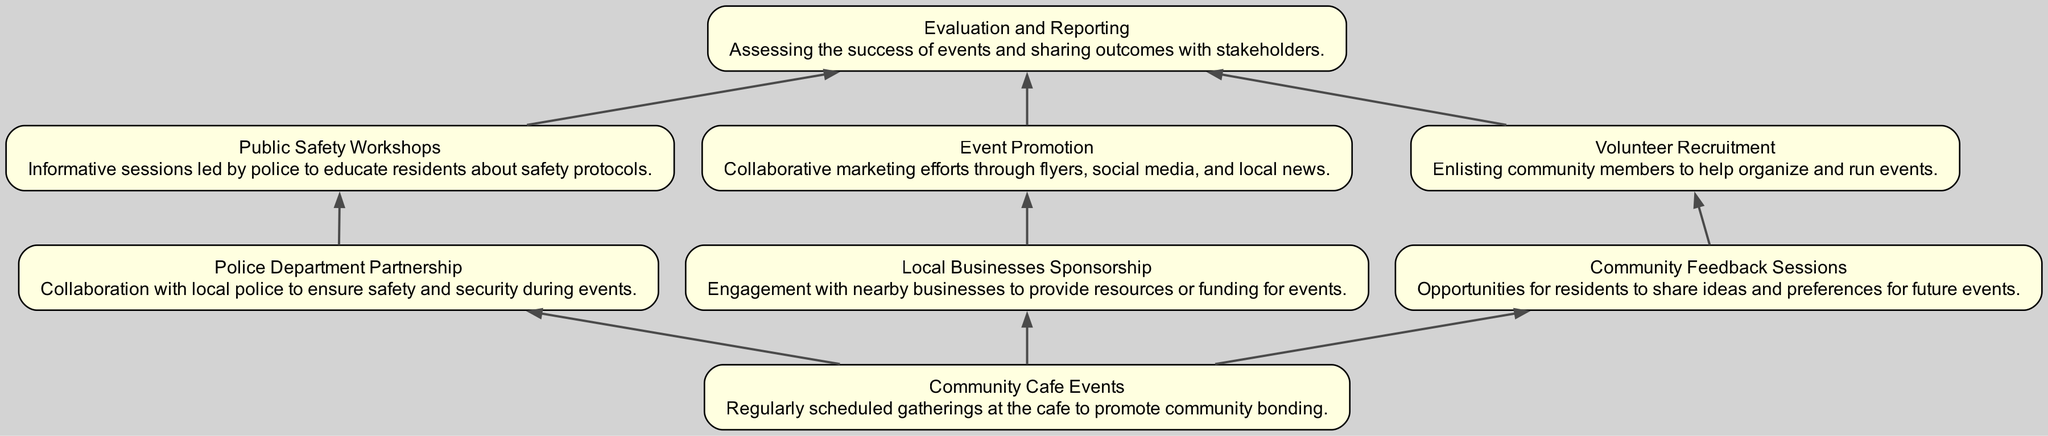What is the main purpose of Community Cafe Events? The main purpose of Community Cafe Events, as described in the diagram, is to promote community bonding through regularly scheduled gatherings.
Answer: Promote community bonding How many nodes are in the diagram? By counting each unique element listed in the diagram, we can see that there are a total of eight distinct nodes present.
Answer: Eight What connects Local Businesses Sponsorship to Evaluation and Reporting? The connection between Local Businesses Sponsorship and Evaluation and Reporting occurs through the Event Promotion, which is sponsored by local businesses.
Answer: Event Promotion Which node leads to Public Safety Workshops? The node that leads to Public Safety Workshops is the Police Department Partnership, indicating a direct connection in the flow of the diagram.
Answer: Police Department Partnership What is the purpose of Volunteer Recruitment? Volunteer Recruitment serves the purpose of enlisting community members to help organize and run events, as outlined in the description in its respective node.
Answer: Enlisting community members What is the relationship between Community Feedback Sessions and Volunteer Recruitment? Community Feedback Sessions foster opportunities for residents to share ideas, which directly leads to Volunteer Recruitment for implementing those ideas in events.
Answer: Directly leads Which node is the starting point of the diagram that has connections to multiple other nodes? The starting point of the diagram with connections to multiple other nodes is Community Cafe Events, as it branches out to several partnerships and feedback efforts.
Answer: Community Cafe Events What is described in Evaluation and Reporting? Evaluation and Reporting is about assessing the success of events and sharing outcomes with stakeholders, providing a necessary reflection on the efforts made during events.
Answer: Assessing success of events What type of events are conducted through the Police Department Partnership? Public Safety Workshops are the type of events conducted through the Police Department Partnership, aiming to educate residents on safety protocols.
Answer: Public Safety Workshops 